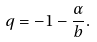Convert formula to latex. <formula><loc_0><loc_0><loc_500><loc_500>q = - 1 - \frac { \alpha } { b } .</formula> 